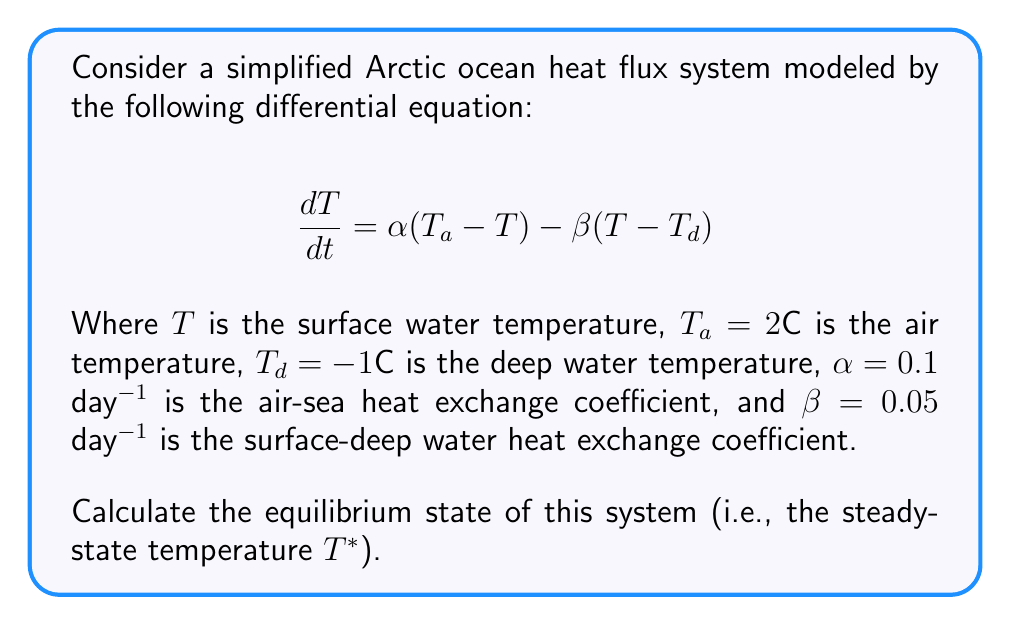What is the answer to this math problem? To find the equilibrium state, we need to set the rate of change of temperature to zero:

$$ \frac{dT}{dt} = 0 $$

Substituting this into our original equation:

$$ 0 = \alpha(T_a - T^*) - \beta(T^* - T_d) $$

Now, let's substitute the given values:

$$ 0 = 0.1(2 - T^*) - 0.05(T^* - (-1)) $$

Simplifying:

$$ 0 = 0.2 - 0.1T^* - 0.05T^* + 0.05 $$
$$ 0 = 0.25 - 0.15T^* $$

Solving for $T^*$:

$$ 0.15T^* = 0.25 $$
$$ T^* = \frac{0.25}{0.15} = \frac{5}{3} $$

Therefore, the equilibrium temperature is $T^* = \frac{5}{3}°C$ or approximately 1.67°C.
Answer: $T^* = \frac{5}{3}°C$ 